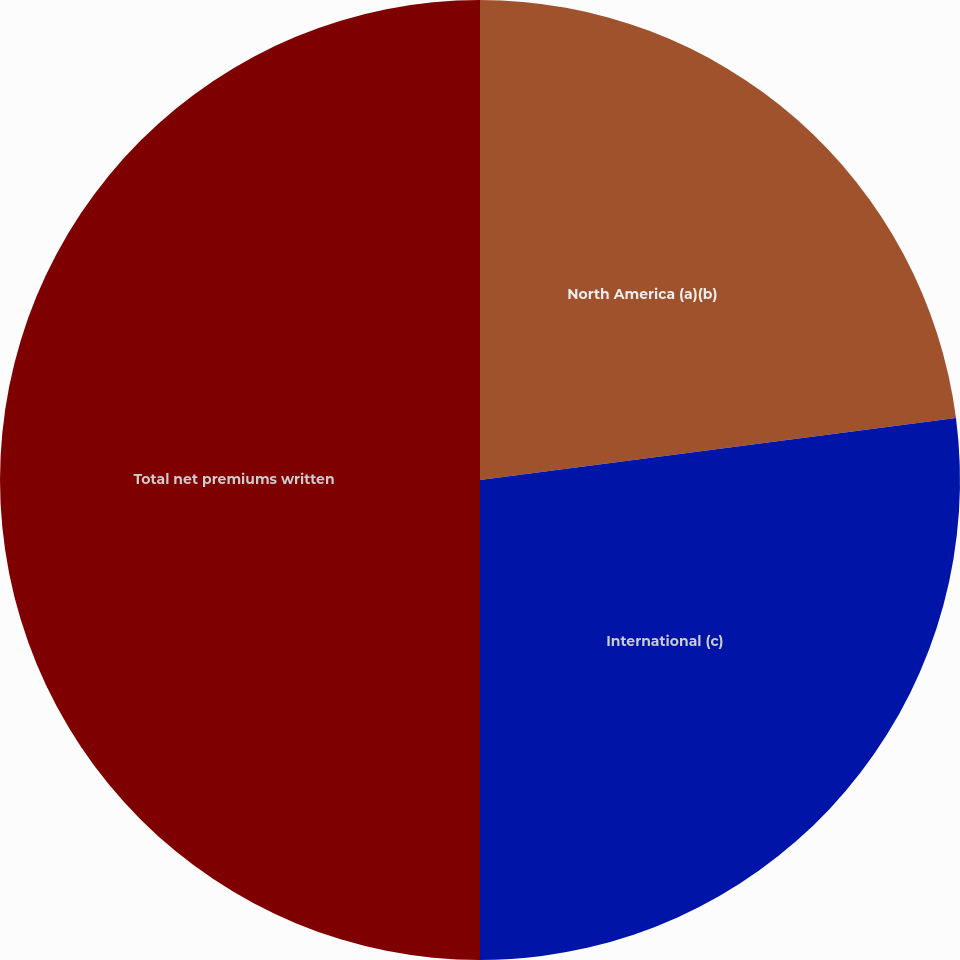Convert chart. <chart><loc_0><loc_0><loc_500><loc_500><pie_chart><fcel>North America (a)(b)<fcel>International (c)<fcel>Total net premiums written<nl><fcel>22.94%<fcel>27.06%<fcel>50.0%<nl></chart> 